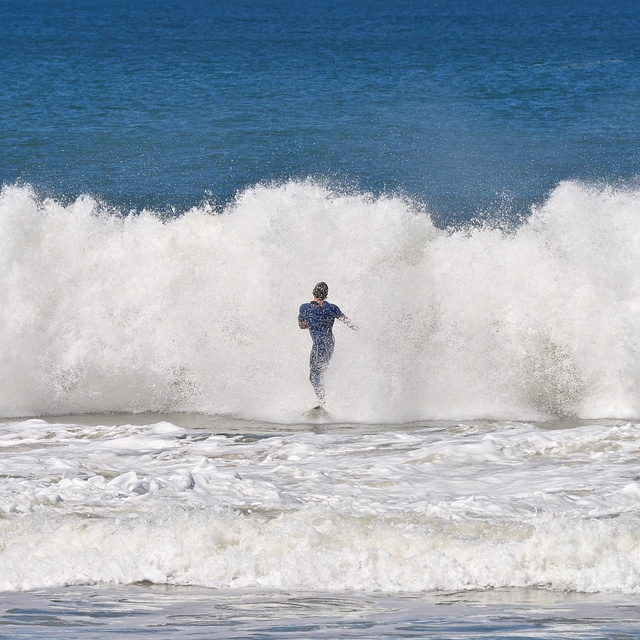Describe the objects in this image and their specific colors. I can see people in blue, gray, darkgray, lightgray, and navy tones and surfboard in blue, darkgray, lightgray, and gray tones in this image. 